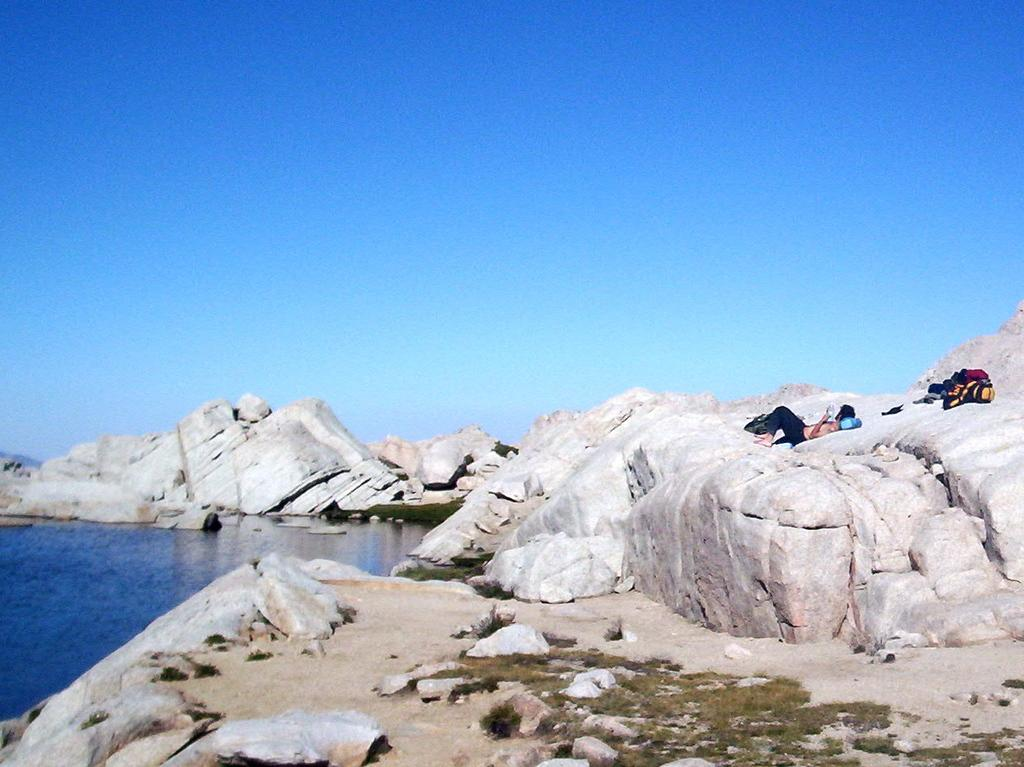What type of natural elements can be seen in the image? There are rocks and water visible in the image. Where is the water located in the image? The water is on the left side of the image. What is visible at the top of the image? The sky is visible at the top of the image. Can you see a boy rolling down the hill in the image? There is no boy or hill present in the image. 